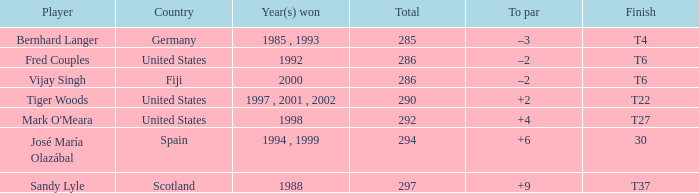Which golfer's score is 2 strokes above par? Tiger Woods. 